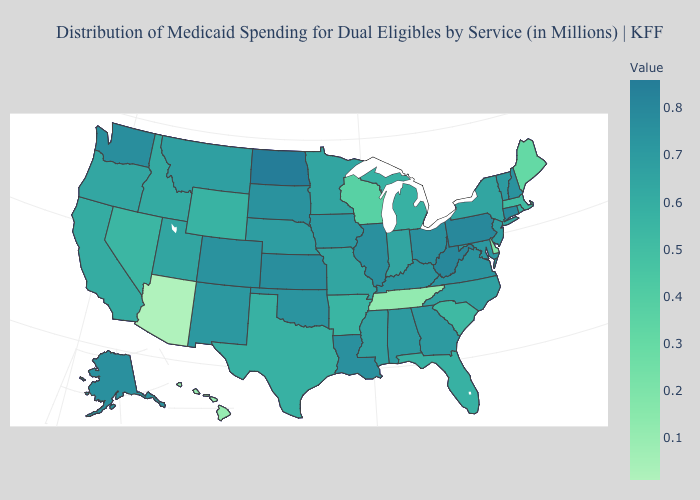Does the map have missing data?
Give a very brief answer. No. Does New Hampshire have a higher value than Indiana?
Answer briefly. Yes. Does the map have missing data?
Short answer required. No. Among the states that border Virginia , which have the lowest value?
Answer briefly. Tennessee. 